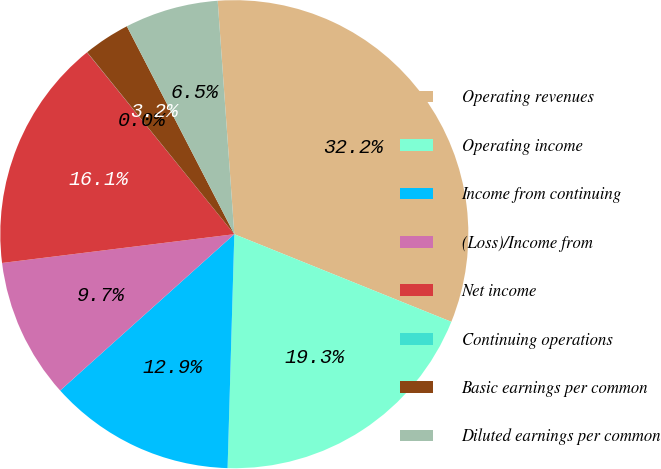<chart> <loc_0><loc_0><loc_500><loc_500><pie_chart><fcel>Operating revenues<fcel>Operating income<fcel>Income from continuing<fcel>(Loss)/Income from<fcel>Net income<fcel>Continuing operations<fcel>Basic earnings per common<fcel>Diluted earnings per common<nl><fcel>32.24%<fcel>19.35%<fcel>12.9%<fcel>9.68%<fcel>16.13%<fcel>0.01%<fcel>3.23%<fcel>6.46%<nl></chart> 